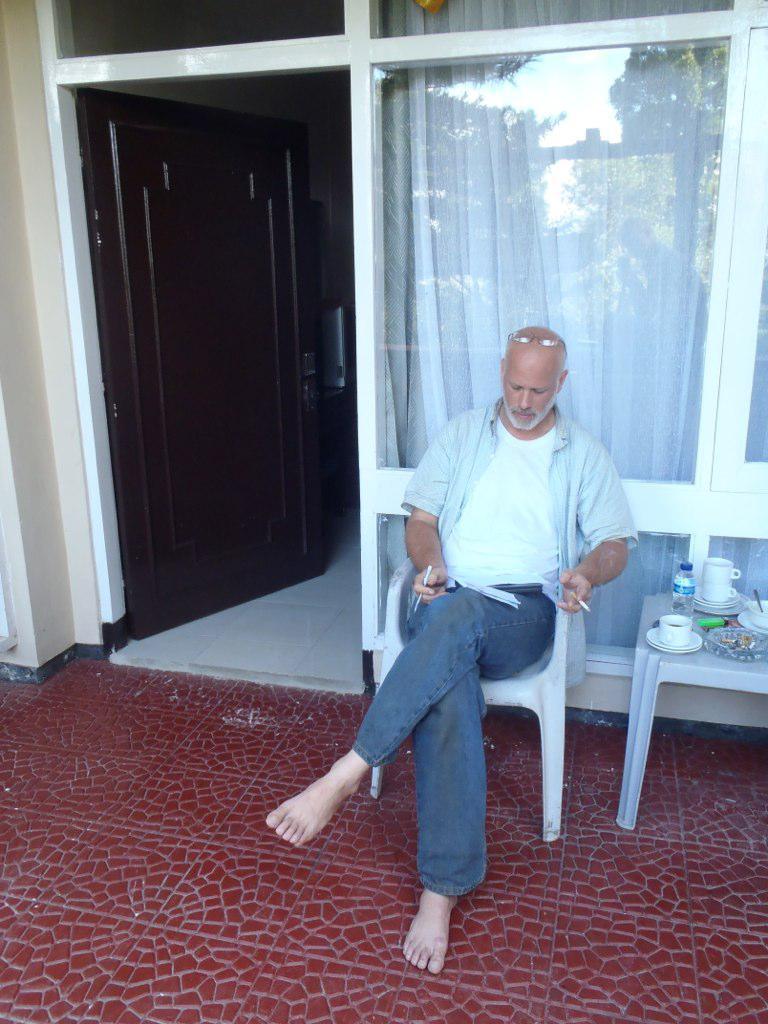Describe this image in one or two sentences. As we can see in the picture that a man is sitting on a chair and he is holding something in his hand. Beside him there is a table and a water bottle, tea cup is placed. This is a door. 